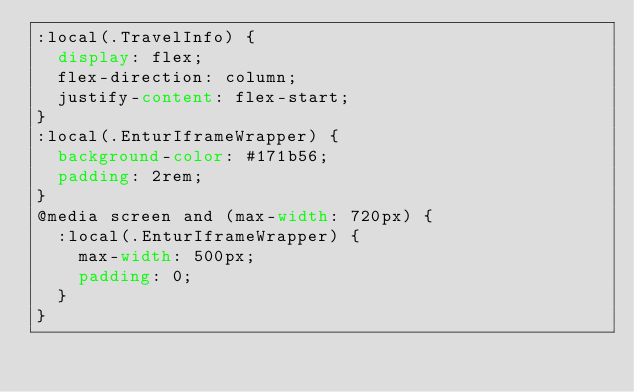Convert code to text. <code><loc_0><loc_0><loc_500><loc_500><_CSS_>:local(.TravelInfo) {
  display: flex;
  flex-direction: column;
  justify-content: flex-start;
}
:local(.EnturIframeWrapper) {
  background-color: #171b56;
  padding: 2rem;
}
@media screen and (max-width: 720px) {
  :local(.EnturIframeWrapper) {
    max-width: 500px;
    padding: 0;
  }
}
</code> 